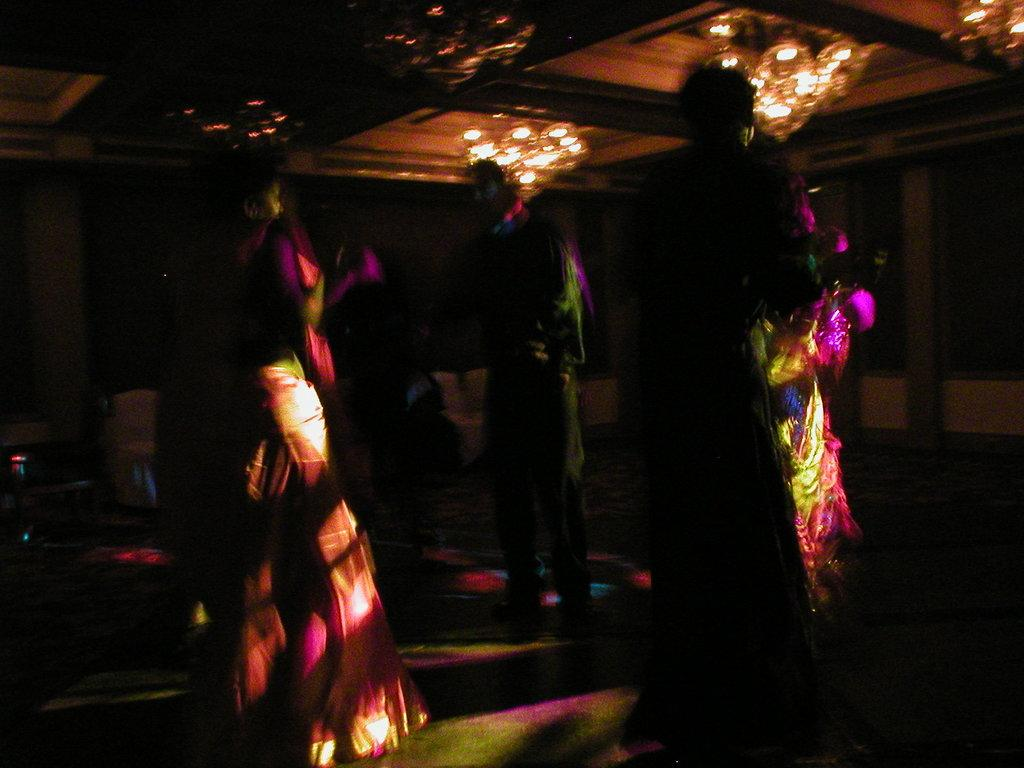How many people are in the image? There are three persons standing in the image. Where are the persons standing? The persons are standing on the floor. What can be seen hanging from the ceiling in the image? There are chandeliers hanging from the ceiling in the image. What type of furniture is visible in the background of the image? Chairs are present in the background of the image. What type of truck can be seen parked outside the room in the image? There is no truck visible in the image; it only shows three persons standing on the floor, chandeliers hanging from the ceiling, and chairs in the background. 